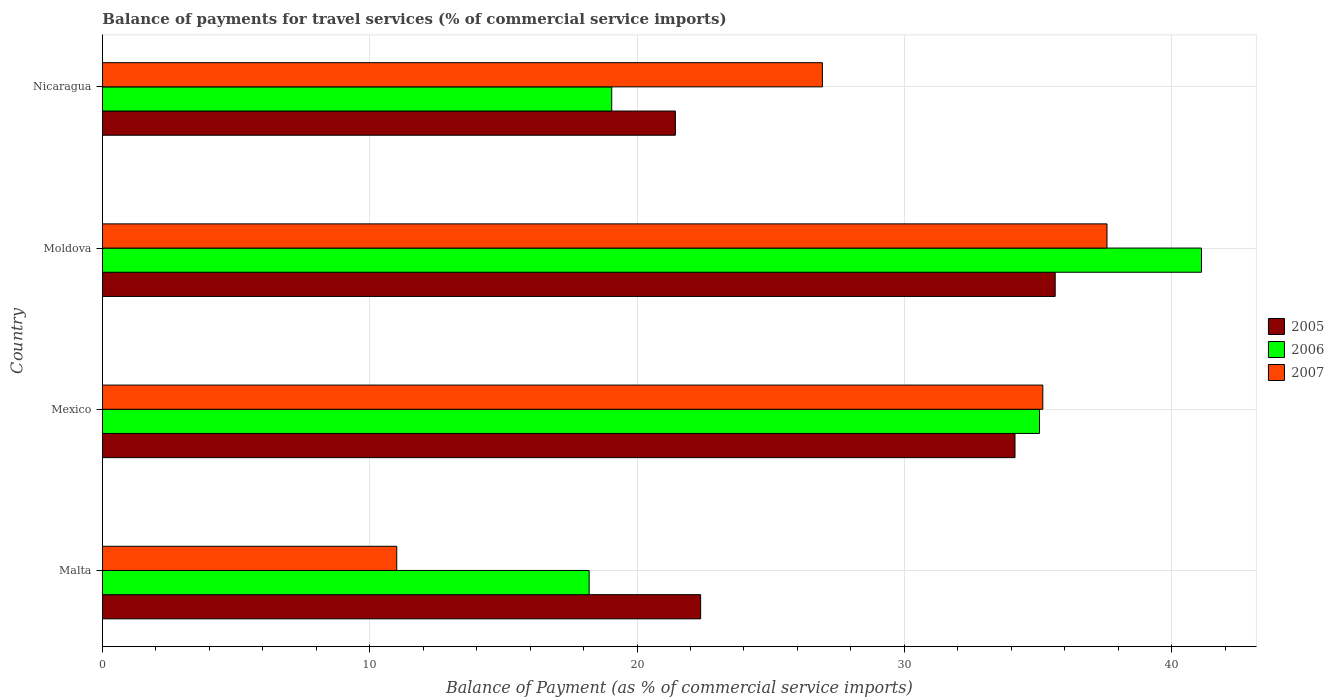How many groups of bars are there?
Your answer should be very brief. 4. Are the number of bars on each tick of the Y-axis equal?
Your response must be concise. Yes. What is the label of the 2nd group of bars from the top?
Provide a short and direct response. Moldova. What is the balance of payments for travel services in 2006 in Mexico?
Offer a terse response. 35.06. Across all countries, what is the maximum balance of payments for travel services in 2005?
Your response must be concise. 35.64. Across all countries, what is the minimum balance of payments for travel services in 2005?
Offer a very short reply. 21.44. In which country was the balance of payments for travel services in 2007 maximum?
Provide a short and direct response. Moldova. In which country was the balance of payments for travel services in 2006 minimum?
Offer a very short reply. Malta. What is the total balance of payments for travel services in 2005 in the graph?
Provide a short and direct response. 113.6. What is the difference between the balance of payments for travel services in 2006 in Malta and that in Moldova?
Your answer should be compact. -22.91. What is the difference between the balance of payments for travel services in 2007 in Moldova and the balance of payments for travel services in 2006 in Malta?
Your response must be concise. 19.37. What is the average balance of payments for travel services in 2006 per country?
Keep it short and to the point. 28.36. What is the difference between the balance of payments for travel services in 2007 and balance of payments for travel services in 2005 in Malta?
Ensure brevity in your answer.  -11.37. What is the ratio of the balance of payments for travel services in 2007 in Moldova to that in Nicaragua?
Offer a terse response. 1.4. What is the difference between the highest and the second highest balance of payments for travel services in 2005?
Offer a terse response. 1.5. What is the difference between the highest and the lowest balance of payments for travel services in 2007?
Keep it short and to the point. 26.57. Is the sum of the balance of payments for travel services in 2006 in Malta and Mexico greater than the maximum balance of payments for travel services in 2005 across all countries?
Your answer should be compact. Yes. How many bars are there?
Give a very brief answer. 12. Are all the bars in the graph horizontal?
Your response must be concise. Yes. What is the difference between two consecutive major ticks on the X-axis?
Offer a terse response. 10. Does the graph contain any zero values?
Your answer should be very brief. No. Where does the legend appear in the graph?
Your answer should be compact. Center right. How many legend labels are there?
Your answer should be very brief. 3. What is the title of the graph?
Offer a very short reply. Balance of payments for travel services (% of commercial service imports). Does "1990" appear as one of the legend labels in the graph?
Offer a very short reply. No. What is the label or title of the X-axis?
Offer a very short reply. Balance of Payment (as % of commercial service imports). What is the label or title of the Y-axis?
Your answer should be compact. Country. What is the Balance of Payment (as % of commercial service imports) of 2005 in Malta?
Your response must be concise. 22.38. What is the Balance of Payment (as % of commercial service imports) of 2006 in Malta?
Offer a terse response. 18.21. What is the Balance of Payment (as % of commercial service imports) in 2007 in Malta?
Your answer should be very brief. 11.01. What is the Balance of Payment (as % of commercial service imports) of 2005 in Mexico?
Make the answer very short. 34.14. What is the Balance of Payment (as % of commercial service imports) in 2006 in Mexico?
Ensure brevity in your answer.  35.06. What is the Balance of Payment (as % of commercial service imports) of 2007 in Mexico?
Provide a short and direct response. 35.18. What is the Balance of Payment (as % of commercial service imports) in 2005 in Moldova?
Give a very brief answer. 35.64. What is the Balance of Payment (as % of commercial service imports) in 2006 in Moldova?
Make the answer very short. 41.12. What is the Balance of Payment (as % of commercial service imports) in 2007 in Moldova?
Offer a terse response. 37.58. What is the Balance of Payment (as % of commercial service imports) of 2005 in Nicaragua?
Keep it short and to the point. 21.44. What is the Balance of Payment (as % of commercial service imports) of 2006 in Nicaragua?
Your response must be concise. 19.05. What is the Balance of Payment (as % of commercial service imports) of 2007 in Nicaragua?
Give a very brief answer. 26.94. Across all countries, what is the maximum Balance of Payment (as % of commercial service imports) of 2005?
Your answer should be very brief. 35.64. Across all countries, what is the maximum Balance of Payment (as % of commercial service imports) in 2006?
Keep it short and to the point. 41.12. Across all countries, what is the maximum Balance of Payment (as % of commercial service imports) of 2007?
Keep it short and to the point. 37.58. Across all countries, what is the minimum Balance of Payment (as % of commercial service imports) of 2005?
Ensure brevity in your answer.  21.44. Across all countries, what is the minimum Balance of Payment (as % of commercial service imports) of 2006?
Ensure brevity in your answer.  18.21. Across all countries, what is the minimum Balance of Payment (as % of commercial service imports) of 2007?
Provide a short and direct response. 11.01. What is the total Balance of Payment (as % of commercial service imports) of 2005 in the graph?
Offer a terse response. 113.6. What is the total Balance of Payment (as % of commercial service imports) in 2006 in the graph?
Keep it short and to the point. 113.44. What is the total Balance of Payment (as % of commercial service imports) in 2007 in the graph?
Offer a very short reply. 110.71. What is the difference between the Balance of Payment (as % of commercial service imports) in 2005 in Malta and that in Mexico?
Ensure brevity in your answer.  -11.76. What is the difference between the Balance of Payment (as % of commercial service imports) in 2006 in Malta and that in Mexico?
Your answer should be compact. -16.85. What is the difference between the Balance of Payment (as % of commercial service imports) in 2007 in Malta and that in Mexico?
Provide a succinct answer. -24.17. What is the difference between the Balance of Payment (as % of commercial service imports) in 2005 in Malta and that in Moldova?
Your answer should be compact. -13.26. What is the difference between the Balance of Payment (as % of commercial service imports) in 2006 in Malta and that in Moldova?
Provide a succinct answer. -22.91. What is the difference between the Balance of Payment (as % of commercial service imports) in 2007 in Malta and that in Moldova?
Give a very brief answer. -26.57. What is the difference between the Balance of Payment (as % of commercial service imports) of 2005 in Malta and that in Nicaragua?
Ensure brevity in your answer.  0.94. What is the difference between the Balance of Payment (as % of commercial service imports) in 2006 in Malta and that in Nicaragua?
Keep it short and to the point. -0.84. What is the difference between the Balance of Payment (as % of commercial service imports) in 2007 in Malta and that in Nicaragua?
Ensure brevity in your answer.  -15.93. What is the difference between the Balance of Payment (as % of commercial service imports) of 2005 in Mexico and that in Moldova?
Your answer should be compact. -1.5. What is the difference between the Balance of Payment (as % of commercial service imports) of 2006 in Mexico and that in Moldova?
Your response must be concise. -6.06. What is the difference between the Balance of Payment (as % of commercial service imports) in 2007 in Mexico and that in Moldova?
Make the answer very short. -2.4. What is the difference between the Balance of Payment (as % of commercial service imports) in 2005 in Mexico and that in Nicaragua?
Make the answer very short. 12.71. What is the difference between the Balance of Payment (as % of commercial service imports) of 2006 in Mexico and that in Nicaragua?
Your answer should be compact. 16. What is the difference between the Balance of Payment (as % of commercial service imports) in 2007 in Mexico and that in Nicaragua?
Offer a terse response. 8.25. What is the difference between the Balance of Payment (as % of commercial service imports) of 2005 in Moldova and that in Nicaragua?
Offer a terse response. 14.21. What is the difference between the Balance of Payment (as % of commercial service imports) of 2006 in Moldova and that in Nicaragua?
Make the answer very short. 22.06. What is the difference between the Balance of Payment (as % of commercial service imports) of 2007 in Moldova and that in Nicaragua?
Your response must be concise. 10.65. What is the difference between the Balance of Payment (as % of commercial service imports) of 2005 in Malta and the Balance of Payment (as % of commercial service imports) of 2006 in Mexico?
Offer a very short reply. -12.68. What is the difference between the Balance of Payment (as % of commercial service imports) in 2005 in Malta and the Balance of Payment (as % of commercial service imports) in 2007 in Mexico?
Keep it short and to the point. -12.8. What is the difference between the Balance of Payment (as % of commercial service imports) in 2006 in Malta and the Balance of Payment (as % of commercial service imports) in 2007 in Mexico?
Offer a very short reply. -16.97. What is the difference between the Balance of Payment (as % of commercial service imports) of 2005 in Malta and the Balance of Payment (as % of commercial service imports) of 2006 in Moldova?
Your response must be concise. -18.74. What is the difference between the Balance of Payment (as % of commercial service imports) in 2005 in Malta and the Balance of Payment (as % of commercial service imports) in 2007 in Moldova?
Keep it short and to the point. -15.2. What is the difference between the Balance of Payment (as % of commercial service imports) of 2006 in Malta and the Balance of Payment (as % of commercial service imports) of 2007 in Moldova?
Provide a succinct answer. -19.37. What is the difference between the Balance of Payment (as % of commercial service imports) of 2005 in Malta and the Balance of Payment (as % of commercial service imports) of 2006 in Nicaragua?
Ensure brevity in your answer.  3.33. What is the difference between the Balance of Payment (as % of commercial service imports) of 2005 in Malta and the Balance of Payment (as % of commercial service imports) of 2007 in Nicaragua?
Provide a short and direct response. -4.56. What is the difference between the Balance of Payment (as % of commercial service imports) of 2006 in Malta and the Balance of Payment (as % of commercial service imports) of 2007 in Nicaragua?
Provide a succinct answer. -8.73. What is the difference between the Balance of Payment (as % of commercial service imports) of 2005 in Mexico and the Balance of Payment (as % of commercial service imports) of 2006 in Moldova?
Keep it short and to the point. -6.98. What is the difference between the Balance of Payment (as % of commercial service imports) of 2005 in Mexico and the Balance of Payment (as % of commercial service imports) of 2007 in Moldova?
Your response must be concise. -3.44. What is the difference between the Balance of Payment (as % of commercial service imports) of 2006 in Mexico and the Balance of Payment (as % of commercial service imports) of 2007 in Moldova?
Offer a very short reply. -2.53. What is the difference between the Balance of Payment (as % of commercial service imports) in 2005 in Mexico and the Balance of Payment (as % of commercial service imports) in 2006 in Nicaragua?
Give a very brief answer. 15.09. What is the difference between the Balance of Payment (as % of commercial service imports) in 2005 in Mexico and the Balance of Payment (as % of commercial service imports) in 2007 in Nicaragua?
Keep it short and to the point. 7.21. What is the difference between the Balance of Payment (as % of commercial service imports) in 2006 in Mexico and the Balance of Payment (as % of commercial service imports) in 2007 in Nicaragua?
Offer a terse response. 8.12. What is the difference between the Balance of Payment (as % of commercial service imports) in 2005 in Moldova and the Balance of Payment (as % of commercial service imports) in 2006 in Nicaragua?
Make the answer very short. 16.59. What is the difference between the Balance of Payment (as % of commercial service imports) in 2005 in Moldova and the Balance of Payment (as % of commercial service imports) in 2007 in Nicaragua?
Give a very brief answer. 8.71. What is the difference between the Balance of Payment (as % of commercial service imports) in 2006 in Moldova and the Balance of Payment (as % of commercial service imports) in 2007 in Nicaragua?
Provide a succinct answer. 14.18. What is the average Balance of Payment (as % of commercial service imports) in 2005 per country?
Your answer should be compact. 28.4. What is the average Balance of Payment (as % of commercial service imports) of 2006 per country?
Your response must be concise. 28.36. What is the average Balance of Payment (as % of commercial service imports) in 2007 per country?
Provide a short and direct response. 27.68. What is the difference between the Balance of Payment (as % of commercial service imports) in 2005 and Balance of Payment (as % of commercial service imports) in 2006 in Malta?
Your answer should be compact. 4.17. What is the difference between the Balance of Payment (as % of commercial service imports) of 2005 and Balance of Payment (as % of commercial service imports) of 2007 in Malta?
Offer a terse response. 11.37. What is the difference between the Balance of Payment (as % of commercial service imports) of 2006 and Balance of Payment (as % of commercial service imports) of 2007 in Malta?
Give a very brief answer. 7.2. What is the difference between the Balance of Payment (as % of commercial service imports) of 2005 and Balance of Payment (as % of commercial service imports) of 2006 in Mexico?
Your answer should be compact. -0.92. What is the difference between the Balance of Payment (as % of commercial service imports) in 2005 and Balance of Payment (as % of commercial service imports) in 2007 in Mexico?
Keep it short and to the point. -1.04. What is the difference between the Balance of Payment (as % of commercial service imports) in 2006 and Balance of Payment (as % of commercial service imports) in 2007 in Mexico?
Give a very brief answer. -0.12. What is the difference between the Balance of Payment (as % of commercial service imports) in 2005 and Balance of Payment (as % of commercial service imports) in 2006 in Moldova?
Keep it short and to the point. -5.47. What is the difference between the Balance of Payment (as % of commercial service imports) in 2005 and Balance of Payment (as % of commercial service imports) in 2007 in Moldova?
Give a very brief answer. -1.94. What is the difference between the Balance of Payment (as % of commercial service imports) of 2006 and Balance of Payment (as % of commercial service imports) of 2007 in Moldova?
Keep it short and to the point. 3.54. What is the difference between the Balance of Payment (as % of commercial service imports) of 2005 and Balance of Payment (as % of commercial service imports) of 2006 in Nicaragua?
Make the answer very short. 2.38. What is the difference between the Balance of Payment (as % of commercial service imports) in 2006 and Balance of Payment (as % of commercial service imports) in 2007 in Nicaragua?
Offer a terse response. -7.88. What is the ratio of the Balance of Payment (as % of commercial service imports) in 2005 in Malta to that in Mexico?
Keep it short and to the point. 0.66. What is the ratio of the Balance of Payment (as % of commercial service imports) of 2006 in Malta to that in Mexico?
Offer a very short reply. 0.52. What is the ratio of the Balance of Payment (as % of commercial service imports) of 2007 in Malta to that in Mexico?
Keep it short and to the point. 0.31. What is the ratio of the Balance of Payment (as % of commercial service imports) of 2005 in Malta to that in Moldova?
Ensure brevity in your answer.  0.63. What is the ratio of the Balance of Payment (as % of commercial service imports) of 2006 in Malta to that in Moldova?
Offer a terse response. 0.44. What is the ratio of the Balance of Payment (as % of commercial service imports) of 2007 in Malta to that in Moldova?
Keep it short and to the point. 0.29. What is the ratio of the Balance of Payment (as % of commercial service imports) of 2005 in Malta to that in Nicaragua?
Keep it short and to the point. 1.04. What is the ratio of the Balance of Payment (as % of commercial service imports) of 2006 in Malta to that in Nicaragua?
Your response must be concise. 0.96. What is the ratio of the Balance of Payment (as % of commercial service imports) in 2007 in Malta to that in Nicaragua?
Give a very brief answer. 0.41. What is the ratio of the Balance of Payment (as % of commercial service imports) in 2005 in Mexico to that in Moldova?
Offer a very short reply. 0.96. What is the ratio of the Balance of Payment (as % of commercial service imports) in 2006 in Mexico to that in Moldova?
Give a very brief answer. 0.85. What is the ratio of the Balance of Payment (as % of commercial service imports) in 2007 in Mexico to that in Moldova?
Ensure brevity in your answer.  0.94. What is the ratio of the Balance of Payment (as % of commercial service imports) of 2005 in Mexico to that in Nicaragua?
Your answer should be compact. 1.59. What is the ratio of the Balance of Payment (as % of commercial service imports) of 2006 in Mexico to that in Nicaragua?
Offer a terse response. 1.84. What is the ratio of the Balance of Payment (as % of commercial service imports) of 2007 in Mexico to that in Nicaragua?
Your answer should be very brief. 1.31. What is the ratio of the Balance of Payment (as % of commercial service imports) in 2005 in Moldova to that in Nicaragua?
Your answer should be compact. 1.66. What is the ratio of the Balance of Payment (as % of commercial service imports) of 2006 in Moldova to that in Nicaragua?
Keep it short and to the point. 2.16. What is the ratio of the Balance of Payment (as % of commercial service imports) in 2007 in Moldova to that in Nicaragua?
Offer a terse response. 1.4. What is the difference between the highest and the second highest Balance of Payment (as % of commercial service imports) in 2005?
Give a very brief answer. 1.5. What is the difference between the highest and the second highest Balance of Payment (as % of commercial service imports) in 2006?
Your response must be concise. 6.06. What is the difference between the highest and the second highest Balance of Payment (as % of commercial service imports) in 2007?
Your answer should be very brief. 2.4. What is the difference between the highest and the lowest Balance of Payment (as % of commercial service imports) in 2005?
Your answer should be compact. 14.21. What is the difference between the highest and the lowest Balance of Payment (as % of commercial service imports) in 2006?
Provide a succinct answer. 22.91. What is the difference between the highest and the lowest Balance of Payment (as % of commercial service imports) in 2007?
Your answer should be compact. 26.57. 